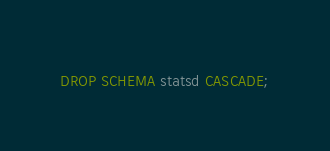<code> <loc_0><loc_0><loc_500><loc_500><_SQL_>DROP SCHEMA statsd CASCADE;
</code> 